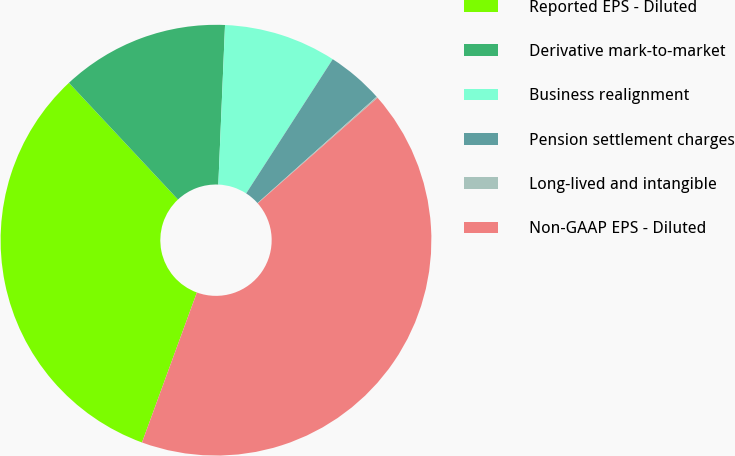Convert chart to OTSL. <chart><loc_0><loc_0><loc_500><loc_500><pie_chart><fcel>Reported EPS - Diluted<fcel>Derivative mark-to-market<fcel>Business realignment<fcel>Pension settlement charges<fcel>Long-lived and intangible<fcel>Non-GAAP EPS - Diluted<nl><fcel>32.46%<fcel>12.63%<fcel>8.45%<fcel>4.28%<fcel>0.1%<fcel>42.08%<nl></chart> 